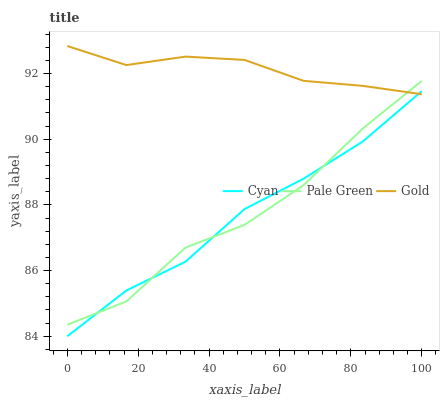Does Cyan have the minimum area under the curve?
Answer yes or no. Yes. Does Gold have the maximum area under the curve?
Answer yes or no. Yes. Does Pale Green have the minimum area under the curve?
Answer yes or no. No. Does Pale Green have the maximum area under the curve?
Answer yes or no. No. Is Gold the smoothest?
Answer yes or no. Yes. Is Pale Green the roughest?
Answer yes or no. Yes. Is Pale Green the smoothest?
Answer yes or no. No. Is Gold the roughest?
Answer yes or no. No. Does Cyan have the lowest value?
Answer yes or no. Yes. Does Pale Green have the lowest value?
Answer yes or no. No. Does Gold have the highest value?
Answer yes or no. Yes. Does Pale Green have the highest value?
Answer yes or no. No. Does Cyan intersect Gold?
Answer yes or no. Yes. Is Cyan less than Gold?
Answer yes or no. No. Is Cyan greater than Gold?
Answer yes or no. No. 